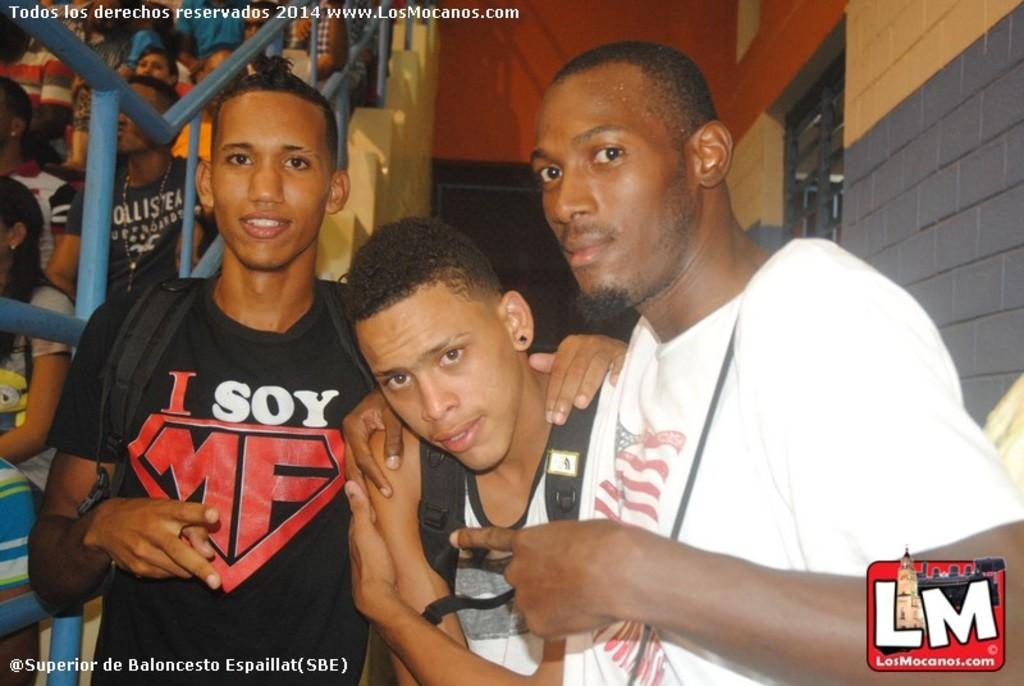How many people are in the image? There are three persons standing in the image. What are the three persons doing in the image? The three persons are posing for the picture. Are there any other people visible in the image besides the three persons? Yes, there are a few audience members seated in the image. What type of robin can be seen making a trade with the audience members in the image? There is no robin or trade present in the image; it features three persons posing for a picture and a few audience members seated. 